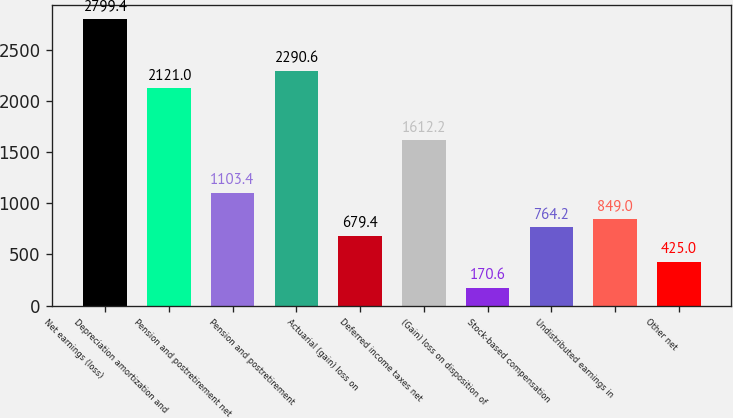<chart> <loc_0><loc_0><loc_500><loc_500><bar_chart><fcel>Net earnings (loss)<fcel>Depreciation amortization and<fcel>Pension and postretirement net<fcel>Pension and postretirement<fcel>Actuarial (gain) loss on<fcel>Deferred income taxes net<fcel>(Gain) loss on disposition of<fcel>Stock-based compensation<fcel>Undistributed earnings in<fcel>Other net<nl><fcel>2799.4<fcel>2121<fcel>1103.4<fcel>2290.6<fcel>679.4<fcel>1612.2<fcel>170.6<fcel>764.2<fcel>849<fcel>425<nl></chart> 